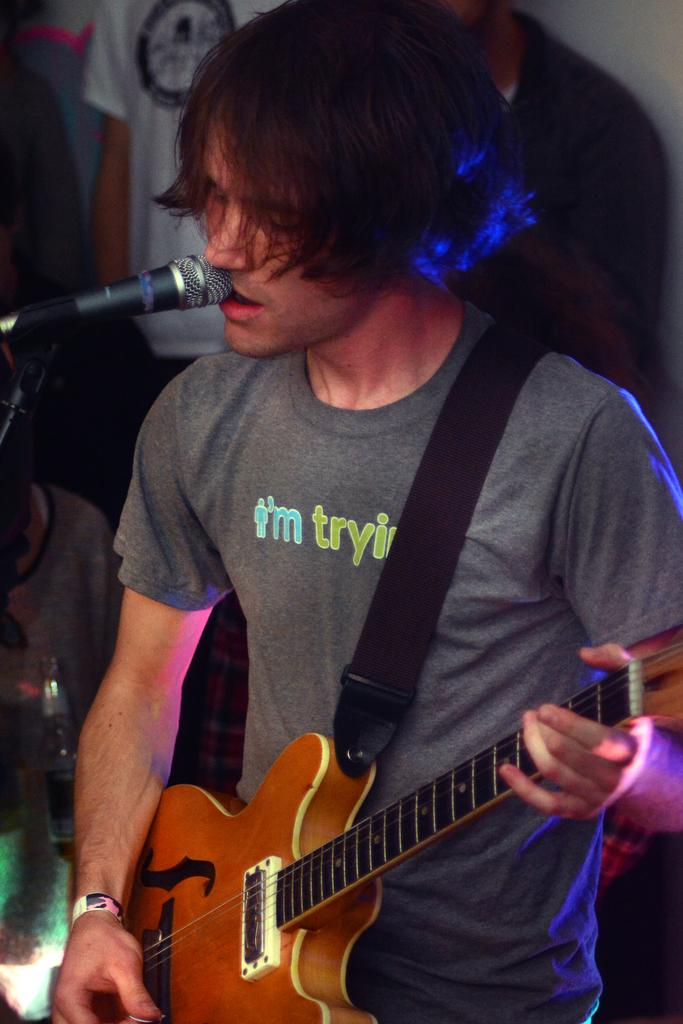What is the person in the image doing? The person is playing the guitar. What is the person wearing in the image? The person is wearing a grey t-shirt. What object is in front of the person? There is a microphone in front of the person. Can you describe the people in the background of the image? There are other people standing in the background. What type of lace is the person using to play the guitar in the image? There is no lace present in the image; the person is playing the guitar with their hands. 